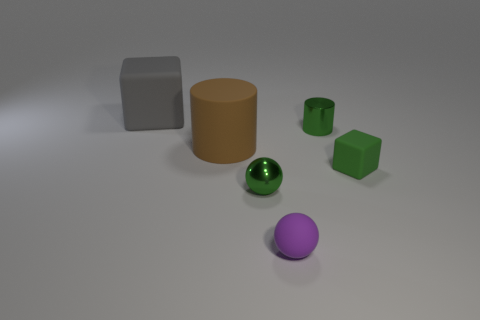There is a small matte object that is to the left of the tiny green thing on the right side of the green metal thing to the right of the small green ball; what shape is it?
Your answer should be very brief. Sphere. There is a large thing that is right of the gray matte thing; is it the same shape as the tiny shiny object that is in front of the green cylinder?
Give a very brief answer. No. What number of other objects are the same material as the brown cylinder?
Offer a terse response. 3. There is a purple thing that is made of the same material as the big gray block; what is its shape?
Ensure brevity in your answer.  Sphere. Do the green ball and the green matte cube have the same size?
Provide a succinct answer. Yes. There is a green metal cylinder to the right of the tiny thing that is in front of the green metallic sphere; what is its size?
Offer a terse response. Small. What is the shape of the shiny thing that is the same color as the metal sphere?
Offer a very short reply. Cylinder. How many cubes are either red metal things or large objects?
Offer a very short reply. 1. There is a rubber sphere; does it have the same size as the brown cylinder on the left side of the small green matte object?
Ensure brevity in your answer.  No. Is the number of green spheres that are to the left of the brown thing greater than the number of green rubber cylinders?
Offer a very short reply. No. 